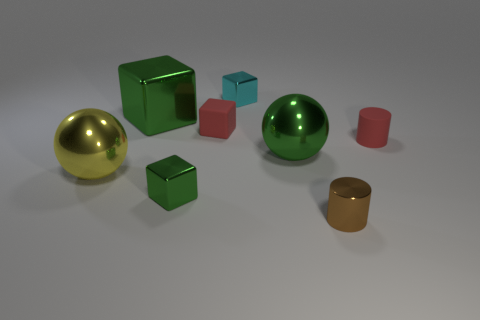Subtract all red cubes. How many cubes are left? 3 Subtract all gray cylinders. How many green blocks are left? 2 Add 1 small blue matte things. How many objects exist? 9 Subtract all red blocks. How many blocks are left? 3 Subtract 2 blocks. How many blocks are left? 2 Subtract all balls. How many objects are left? 6 Subtract all cyan cubes. Subtract all purple spheres. How many cubes are left? 3 Subtract all large green metal cubes. Subtract all tiny gray matte spheres. How many objects are left? 7 Add 3 tiny cyan objects. How many tiny cyan objects are left? 4 Add 2 big green cubes. How many big green cubes exist? 3 